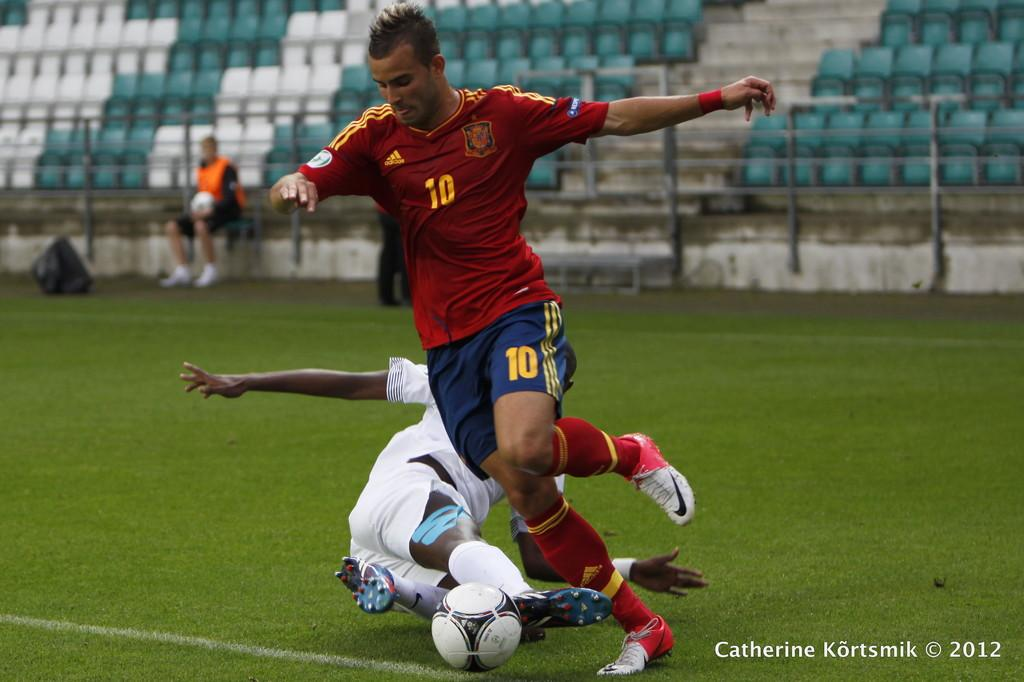<image>
Render a clear and concise summary of the photo. Player number 10 goes for the soccer ball while another player falls to the ground. 